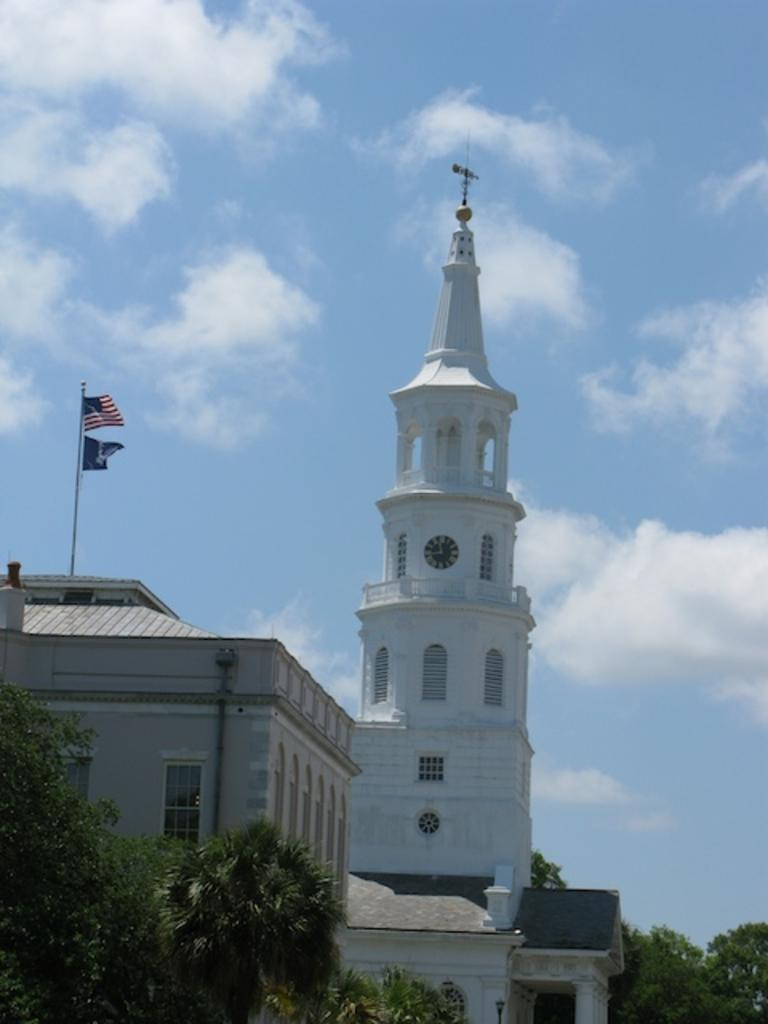What type of structures are visible in the image? There are buildings in the image. What is located above the buildings? There is a clock tower above the buildings. What can be seen on the left side building? There are flags on the left side building. What is in front of the building with the clock tower? Trees are in front of the building with the clock tower. What is visible in the background of the image? The sky is visible in the image. What can be observed in the sky? Clouds are present in the sky. What type of hair can be seen on the doctor in the image? There is no doctor or hair present in the image. How does the island in the image affect the architecture of the buildings? There is no island present in the image, so its impact on the architecture cannot be determined. 